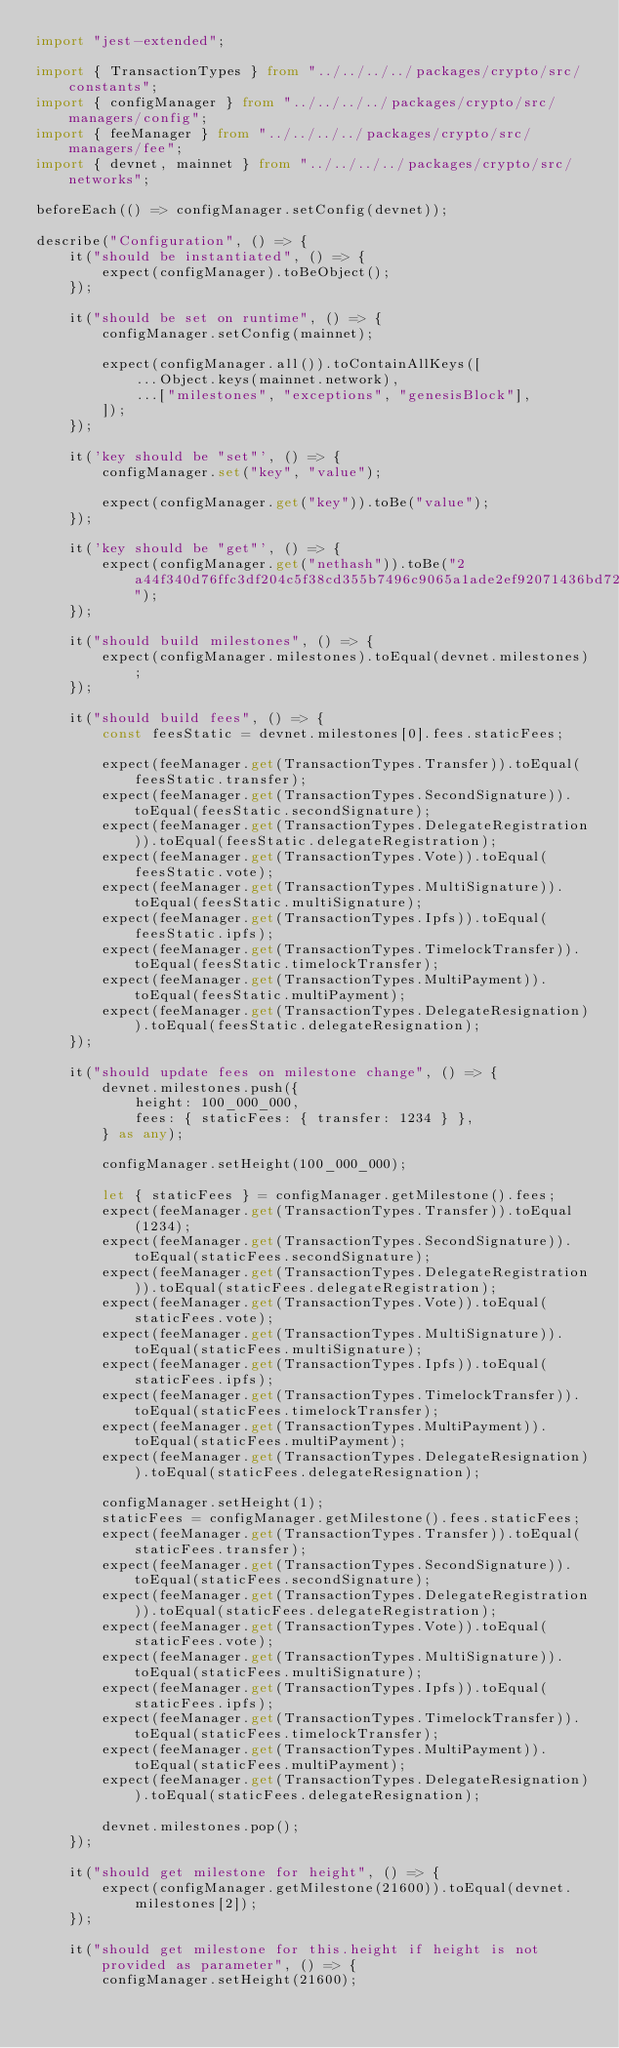<code> <loc_0><loc_0><loc_500><loc_500><_TypeScript_>import "jest-extended";

import { TransactionTypes } from "../../../../packages/crypto/src/constants";
import { configManager } from "../../../../packages/crypto/src/managers/config";
import { feeManager } from "../../../../packages/crypto/src/managers/fee";
import { devnet, mainnet } from "../../../../packages/crypto/src/networks";

beforeEach(() => configManager.setConfig(devnet));

describe("Configuration", () => {
    it("should be instantiated", () => {
        expect(configManager).toBeObject();
    });

    it("should be set on runtime", () => {
        configManager.setConfig(mainnet);

        expect(configManager.all()).toContainAllKeys([
            ...Object.keys(mainnet.network),
            ...["milestones", "exceptions", "genesisBlock"],
        ]);
    });

    it('key should be "set"', () => {
        configManager.set("key", "value");

        expect(configManager.get("key")).toBe("value");
    });

    it('key should be "get"', () => {
        expect(configManager.get("nethash")).toBe("2a44f340d76ffc3df204c5f38cd355b7496c9065a1ade2ef92071436bd72e867");
    });

    it("should build milestones", () => {
        expect(configManager.milestones).toEqual(devnet.milestones);
    });

    it("should build fees", () => {
        const feesStatic = devnet.milestones[0].fees.staticFees;

        expect(feeManager.get(TransactionTypes.Transfer)).toEqual(feesStatic.transfer);
        expect(feeManager.get(TransactionTypes.SecondSignature)).toEqual(feesStatic.secondSignature);
        expect(feeManager.get(TransactionTypes.DelegateRegistration)).toEqual(feesStatic.delegateRegistration);
        expect(feeManager.get(TransactionTypes.Vote)).toEqual(feesStatic.vote);
        expect(feeManager.get(TransactionTypes.MultiSignature)).toEqual(feesStatic.multiSignature);
        expect(feeManager.get(TransactionTypes.Ipfs)).toEqual(feesStatic.ipfs);
        expect(feeManager.get(TransactionTypes.TimelockTransfer)).toEqual(feesStatic.timelockTransfer);
        expect(feeManager.get(TransactionTypes.MultiPayment)).toEqual(feesStatic.multiPayment);
        expect(feeManager.get(TransactionTypes.DelegateResignation)).toEqual(feesStatic.delegateResignation);
    });

    it("should update fees on milestone change", () => {
        devnet.milestones.push({
            height: 100_000_000,
            fees: { staticFees: { transfer: 1234 } },
        } as any);

        configManager.setHeight(100_000_000);

        let { staticFees } = configManager.getMilestone().fees;
        expect(feeManager.get(TransactionTypes.Transfer)).toEqual(1234);
        expect(feeManager.get(TransactionTypes.SecondSignature)).toEqual(staticFees.secondSignature);
        expect(feeManager.get(TransactionTypes.DelegateRegistration)).toEqual(staticFees.delegateRegistration);
        expect(feeManager.get(TransactionTypes.Vote)).toEqual(staticFees.vote);
        expect(feeManager.get(TransactionTypes.MultiSignature)).toEqual(staticFees.multiSignature);
        expect(feeManager.get(TransactionTypes.Ipfs)).toEqual(staticFees.ipfs);
        expect(feeManager.get(TransactionTypes.TimelockTransfer)).toEqual(staticFees.timelockTransfer);
        expect(feeManager.get(TransactionTypes.MultiPayment)).toEqual(staticFees.multiPayment);
        expect(feeManager.get(TransactionTypes.DelegateResignation)).toEqual(staticFees.delegateResignation);

        configManager.setHeight(1);
        staticFees = configManager.getMilestone().fees.staticFees;
        expect(feeManager.get(TransactionTypes.Transfer)).toEqual(staticFees.transfer);
        expect(feeManager.get(TransactionTypes.SecondSignature)).toEqual(staticFees.secondSignature);
        expect(feeManager.get(TransactionTypes.DelegateRegistration)).toEqual(staticFees.delegateRegistration);
        expect(feeManager.get(TransactionTypes.Vote)).toEqual(staticFees.vote);
        expect(feeManager.get(TransactionTypes.MultiSignature)).toEqual(staticFees.multiSignature);
        expect(feeManager.get(TransactionTypes.Ipfs)).toEqual(staticFees.ipfs);
        expect(feeManager.get(TransactionTypes.TimelockTransfer)).toEqual(staticFees.timelockTransfer);
        expect(feeManager.get(TransactionTypes.MultiPayment)).toEqual(staticFees.multiPayment);
        expect(feeManager.get(TransactionTypes.DelegateResignation)).toEqual(staticFees.delegateResignation);

        devnet.milestones.pop();
    });

    it("should get milestone for height", () => {
        expect(configManager.getMilestone(21600)).toEqual(devnet.milestones[2]);
    });

    it("should get milestone for this.height if height is not provided as parameter", () => {
        configManager.setHeight(21600);</code> 